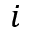Convert formula to latex. <formula><loc_0><loc_0><loc_500><loc_500>i</formula> 